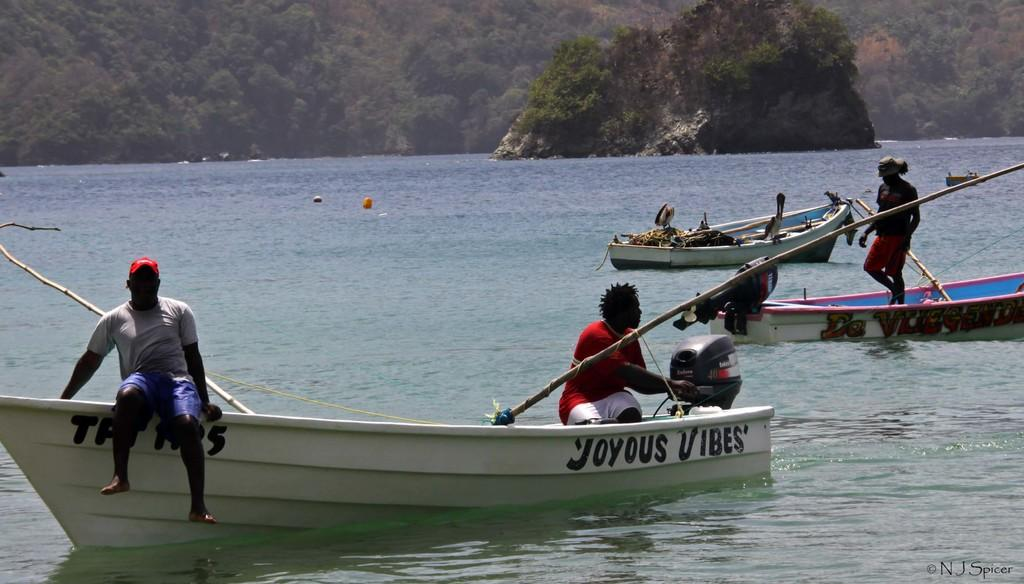What is the man in the image doing? The man is sitting on a boat. What color is the boat the man is sitting on? The boat is white. Are there any other boats visible in the image? Yes, there are other boats in the water. What can be seen in the background of the image? Trees are present in the image. How many houses can be seen in the image? There are no houses present in the image; it features a man sitting on a boat in the water with trees in the background. What type of unit is being used to measure the depth of the water in the image? There is no unit or measurement of water depth visible in the image. 